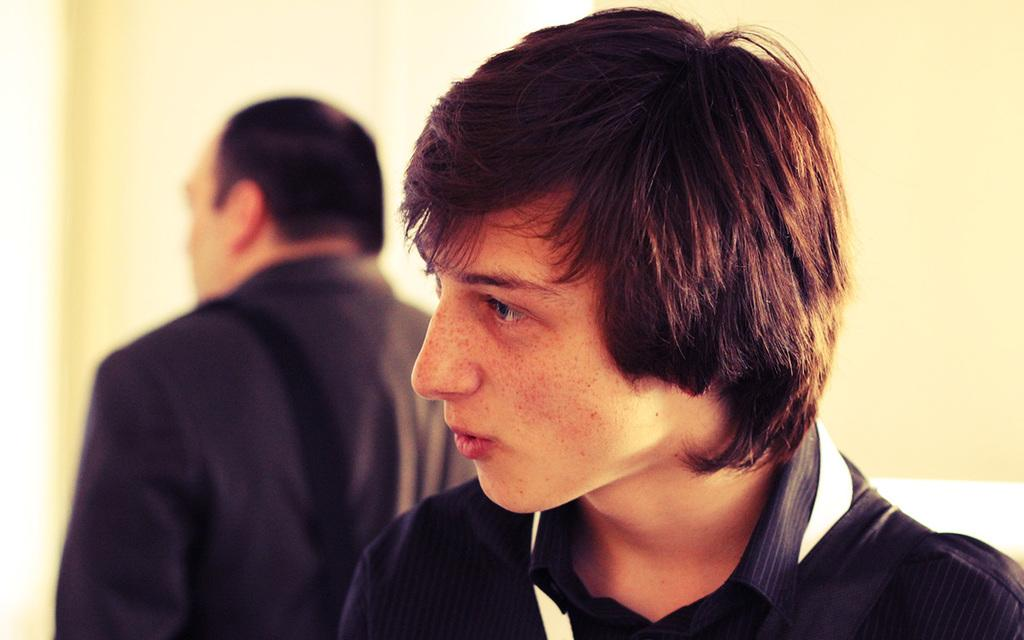Who is present in the image? There is a man in the image. What is the man wearing? The man is wearing a black shirt. Can you describe the background of the image? There is another person and a wall in the background of the image. What type of ball is being thrown in the image? There is no ball present in the image. What advice does the man in the image give to the person in the background? The image does not show any interaction between the man and the person in the background, so it is not possible to determine if advice is being given. 